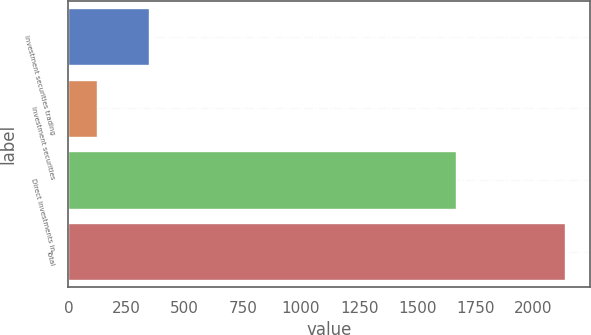<chart> <loc_0><loc_0><loc_500><loc_500><bar_chart><fcel>Investment securities trading<fcel>Investment securities<fcel>Direct investments in<fcel>Total<nl><fcel>346<fcel>124<fcel>1666.3<fcel>2136.3<nl></chart> 